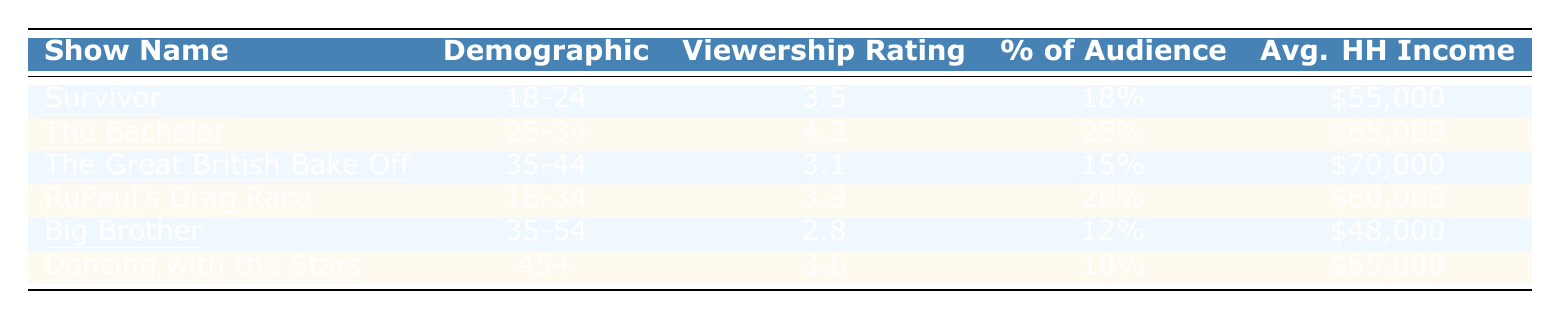What is the viewership rating for "The Bachelor"? The viewership rating for "The Bachelor" is directly listed in the table under the corresponding show name. It shows a rating of 4.2.
Answer: 4.2 Which demographic had the lowest viewership rating? To find the lowest viewership rating, we compare all the ratings listed in the table. The lowest rating is 2.8 for "Big Brother."
Answer: Big Brother (2.8) What is the average household income of the demographic watching "The Great British Bake Off"? The average household income for the demographic watching "The Great British Bake Off," which is in the 35-44 age group, is listed as $70,000.
Answer: $70,000 What percentage of the audience for "Dancing with the Stars" is 45 and older? The percentage of the audience for "Dancing with the Stars," specified in the table, is directly given as 10%.
Answer: 10% Which show had a higher viewership rating: "Survivor" or "RuPaul's Drag Race"? We compare the viewership ratings from the table: "Survivor" has a rating of 3.5 and "RuPaul's Drag Race" has a rating of 3.9. Therefore, "RuPaul's Drag Race" has the higher rating.
Answer: RuPaul's Drag Race What is the total viewership rating for shows targeted at demographics aged 18-34? The viewership ratings for the demographics aged 18-34 are: "Survivor" (3.5) and "RuPaul's Drag Race" (3.9). Adding these gives 3.5 + 3.9 = 7.4.
Answer: 7.4 Is the average household income of the audience for "Big Brother" higher than $50,000? The average household income for "Big Brother," as per the table, is $48,000, which is less than $50,000. Therefore, the statement is false.
Answer: No Which show attracts the largest percentage of its audience? From the table, we check the percentage of audience values: "The Bachelor" attracts 25%, which is the highest in the list.
Answer: The Bachelor What is the difference in viewership ratings between "The Bachelor" and "Big Brother"? The ratings for "The Bachelor" and "Big Brother" are 4.2 and 2.8, respectively. The difference is 4.2 - 2.8 = 1.4.
Answer: 1.4 Which demographic has the highest average household income among the listed shows? The average household incomes are given for each demographic: "The Great British Bake Off" (70,000), "The Bachelor" (65,000), "RuPaul's Drag Race" (60,000), and "Dancing with the Stars" (55,000) and "Survivor" (55,000). Thus, "The Great British Bake Off" has the highest income.
Answer: The Great British Bake Off If you combine the viewership ratings of "Dancing with the Stars" and "Big Brother," what is the resulting total? The viewership ratings for "Dancing with the Stars" and "Big Brother" are 3.6 and 2.8, respectively. Adding these gives 3.6 + 2.8 = 6.4.
Answer: 6.4 